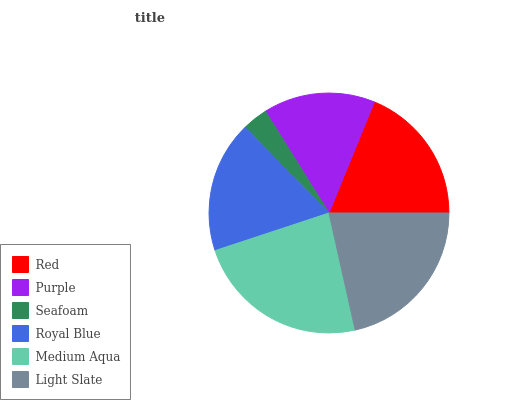Is Seafoam the minimum?
Answer yes or no. Yes. Is Medium Aqua the maximum?
Answer yes or no. Yes. Is Purple the minimum?
Answer yes or no. No. Is Purple the maximum?
Answer yes or no. No. Is Red greater than Purple?
Answer yes or no. Yes. Is Purple less than Red?
Answer yes or no. Yes. Is Purple greater than Red?
Answer yes or no. No. Is Red less than Purple?
Answer yes or no. No. Is Red the high median?
Answer yes or no. Yes. Is Royal Blue the low median?
Answer yes or no. Yes. Is Light Slate the high median?
Answer yes or no. No. Is Red the low median?
Answer yes or no. No. 